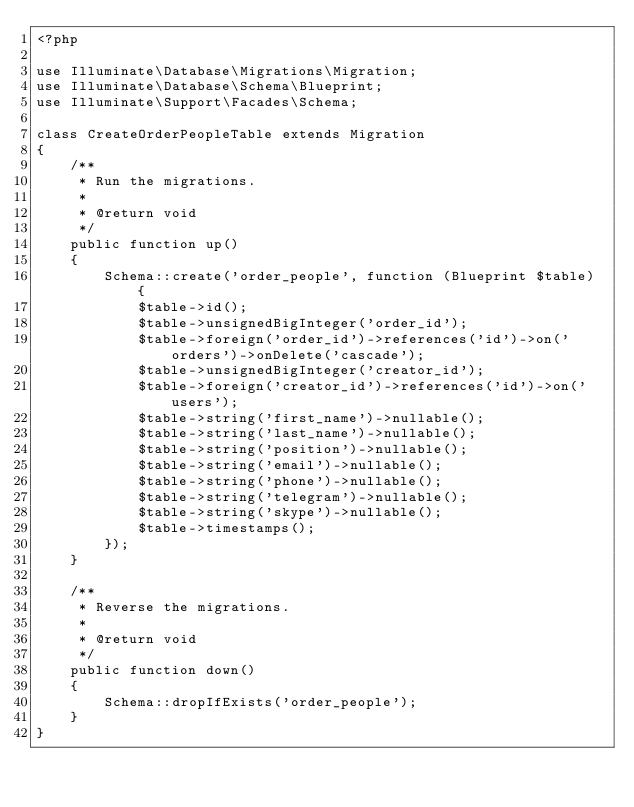<code> <loc_0><loc_0><loc_500><loc_500><_PHP_><?php

use Illuminate\Database\Migrations\Migration;
use Illuminate\Database\Schema\Blueprint;
use Illuminate\Support\Facades\Schema;

class CreateOrderPeopleTable extends Migration
{
    /**
     * Run the migrations.
     *
     * @return void
     */
    public function up()
    {
        Schema::create('order_people', function (Blueprint $table) {
            $table->id();
            $table->unsignedBigInteger('order_id');
            $table->foreign('order_id')->references('id')->on('orders')->onDelete('cascade');
            $table->unsignedBigInteger('creator_id');
            $table->foreign('creator_id')->references('id')->on('users');
            $table->string('first_name')->nullable();
            $table->string('last_name')->nullable();
            $table->string('position')->nullable();
            $table->string('email')->nullable();
            $table->string('phone')->nullable();
            $table->string('telegram')->nullable();
            $table->string('skype')->nullable();
            $table->timestamps();
        });
    }

    /**
     * Reverse the migrations.
     *
     * @return void
     */
    public function down()
    {
        Schema::dropIfExists('order_people');
    }
}
</code> 